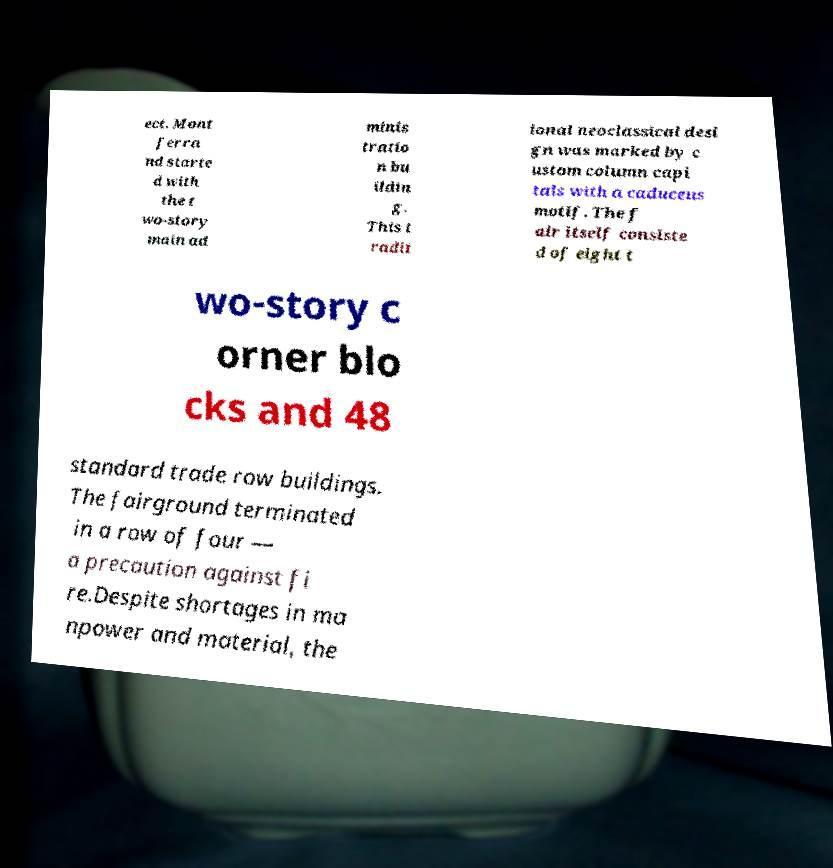Please read and relay the text visible in this image. What does it say? ect. Mont ferra nd starte d with the t wo-story main ad minis tratio n bu ildin g. This t radit ional neoclassical desi gn was marked by c ustom column capi tals with a caduceus motif. The f air itself consiste d of eight t wo-story c orner blo cks and 48 standard trade row buildings. The fairground terminated in a row of four — a precaution against fi re.Despite shortages in ma npower and material, the 